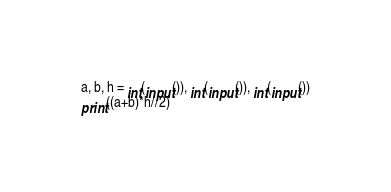<code> <loc_0><loc_0><loc_500><loc_500><_Python_>a, b, h = int(input()), int(input()), int(input())
print((a+b)*h//2)</code> 